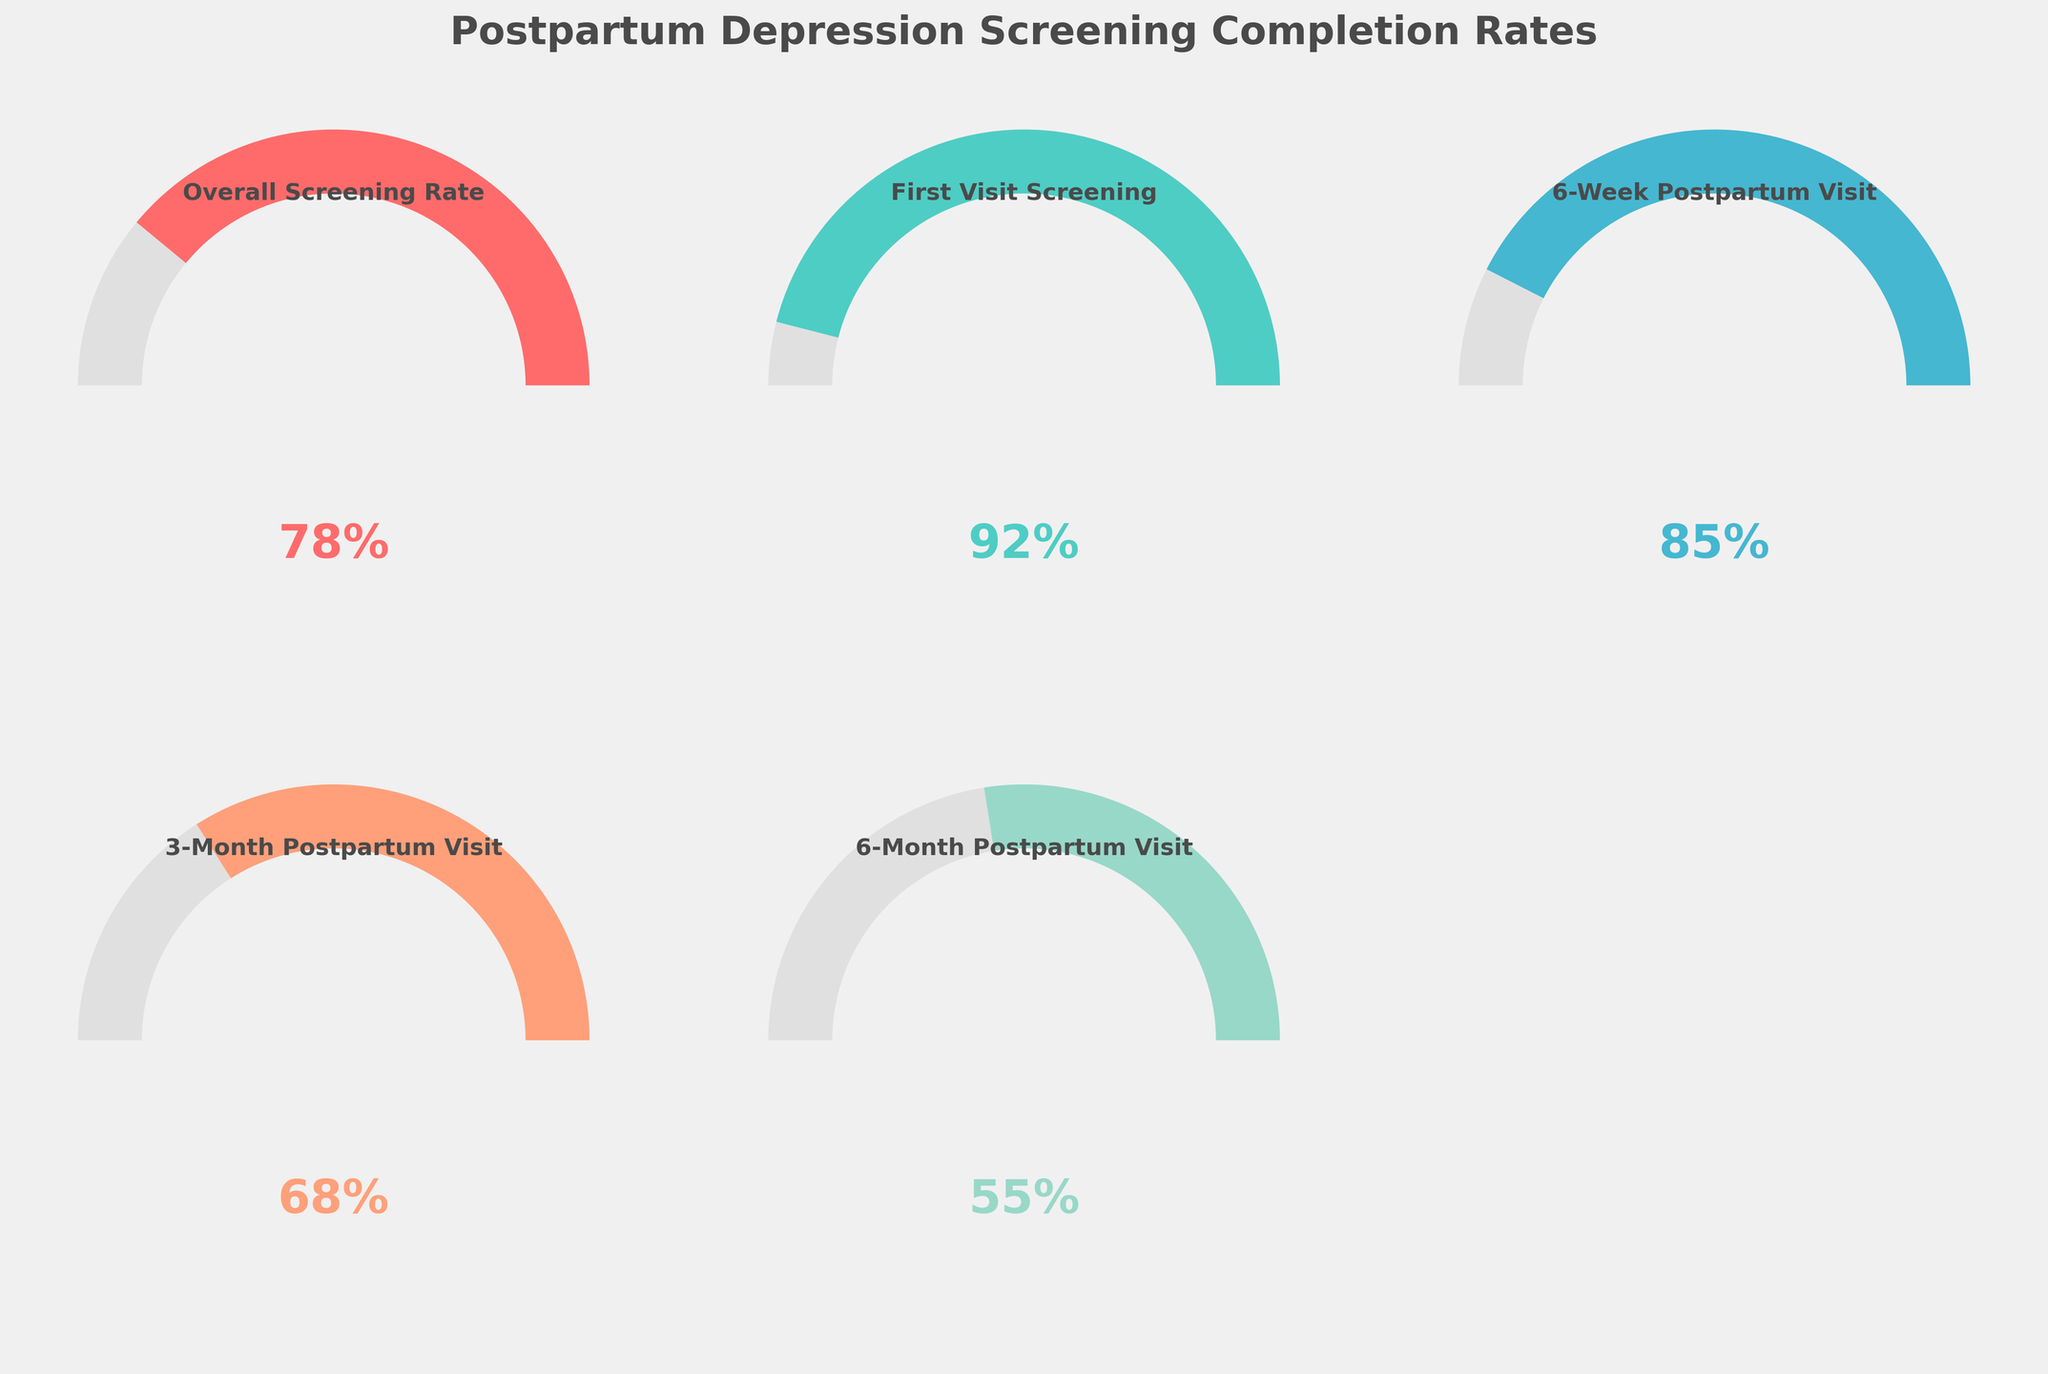What's the overall screening rate for postpartum depression? In the first gauge chart, the overall screening rate is displayed. It reads "Overall Screening Rate" with a value of 78%.
Answer: 78% Which visit has the highest screening completion rate? Among the categories displayed, we observe their respective values. The "First Visit Screening" has the highest value at 92%.
Answer: First Visit Screening Compare the screening rates between the 3-month and 6-month postpartum visits. Which one is higher and by how much? The "3-Month Postpartum Visit" has a value of 68%, while the "6-Month Postpartum Visit" has a value of 55%. To find the difference, subtract 55 from 68: \(68 - 55 = 13\).
Answer: 3-Month Postpartum Visit by 13% What's the average screening rate across all visits? To find the average, add all the rates and divide by the number of categories: \((78 + 92 + 85 + 68 + 55) / 5 = 378 / 5 = 75.6\).
Answer: 75.6% What is the difference in screening completion rates between the overall rate and the 6-week postpartum visit? The overall screening rate is 78%, and the 6-week postpartum visit rate is 85%. Subtracting the overall rate from the 6-week rate gives: \(85 - 78 = 7\).
Answer: 7% Which visits have a screening completion rate lower than the overall rate? The overall rate is 78%. Looking at the gauge values, the "3-Month Postpartum Visit" with 68% and the "6-Month Postpartum Visit" with 55% are both below the overall rate.
Answer: 3-Month Postpartum Visit, 6-Month Postpartum Visit How much higher is the first visit screening rate compared to the 6-month postpartum visit rate? The first visit rate is 92% whereas the 6-month postpartum visit rate is 55%. Subtracting gives: \(92 - 55 = 37\).
Answer: 37% Which screening has the lowest completion rate, and what is the value? Observing the gauge values, the "6-Month Postpartum Visit" has the lowest rate with a value of 55%.
Answer: 6-Month Postpartum Visit, 55% What's the median value of the screening completion rates for different visits? The screening rates are 92%, 85%, 68%, and 55%. To find the median, order the values: 55%, 68%, 85%, 92%. The median is the average of the two middle numbers: \((68 + 85) / 2 = 76.5\).
Answer: 76.5% What's the range of the screening completion rates? The range is calculated as the highest value minus the lowest value. From the values 92% (highest from First Visit Screening) and 55% (lowest from 6-Month Postpartum Visit), the range is: \(92 - 55 = 37\).
Answer: 37% 